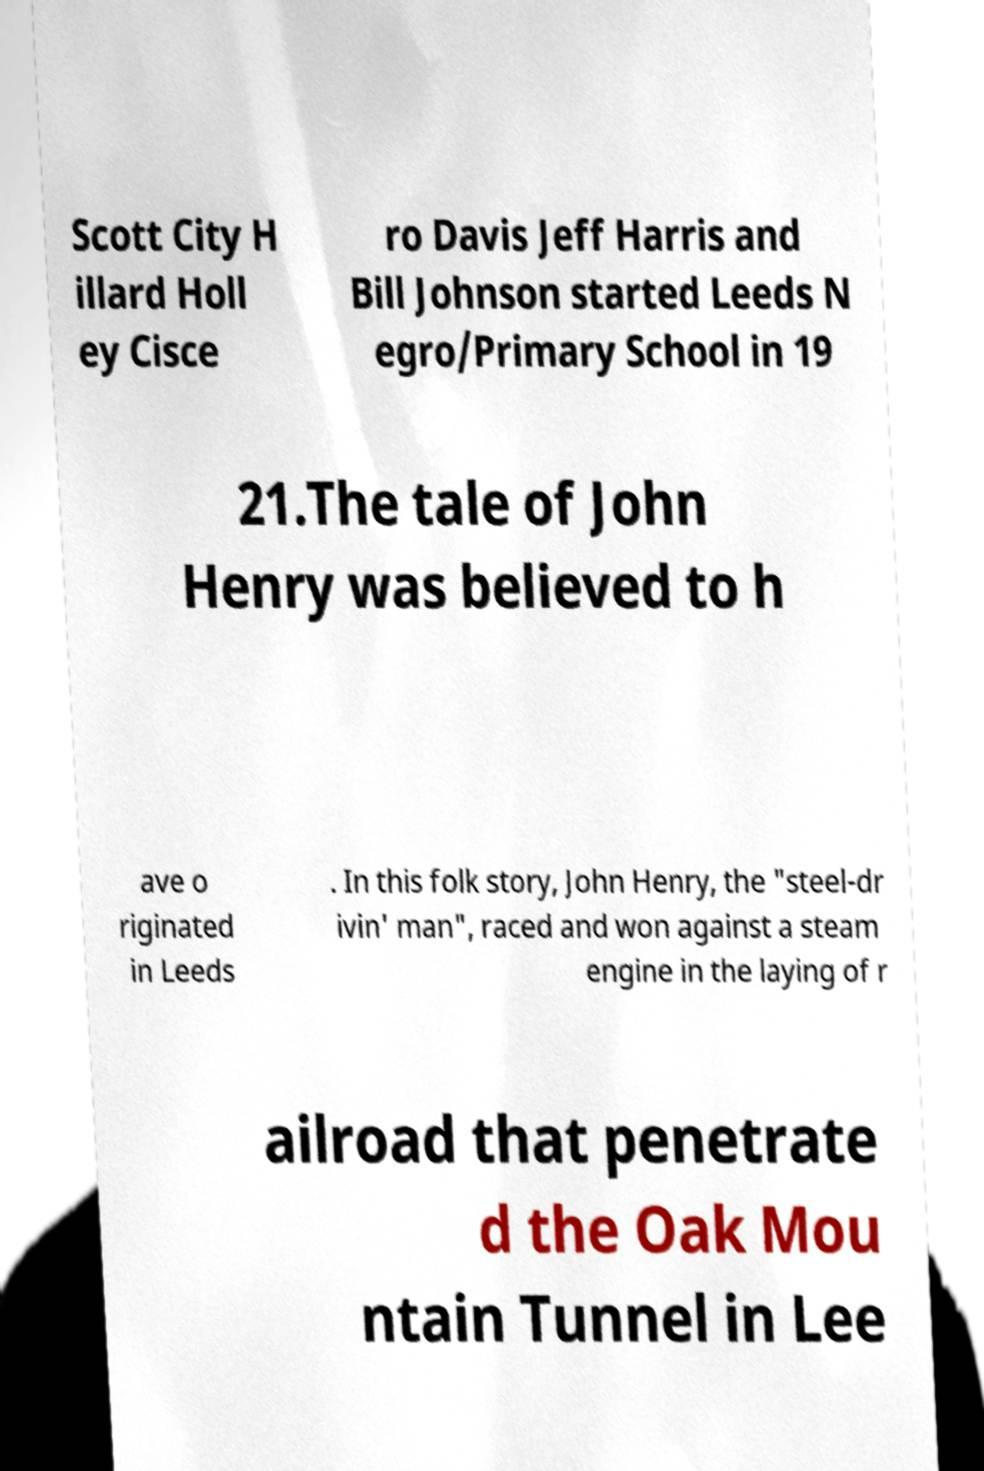What messages or text are displayed in this image? I need them in a readable, typed format. Scott City H illard Holl ey Cisce ro Davis Jeff Harris and Bill Johnson started Leeds N egro/Primary School in 19 21.The tale of John Henry was believed to h ave o riginated in Leeds . In this folk story, John Henry, the "steel-dr ivin' man", raced and won against a steam engine in the laying of r ailroad that penetrate d the Oak Mou ntain Tunnel in Lee 